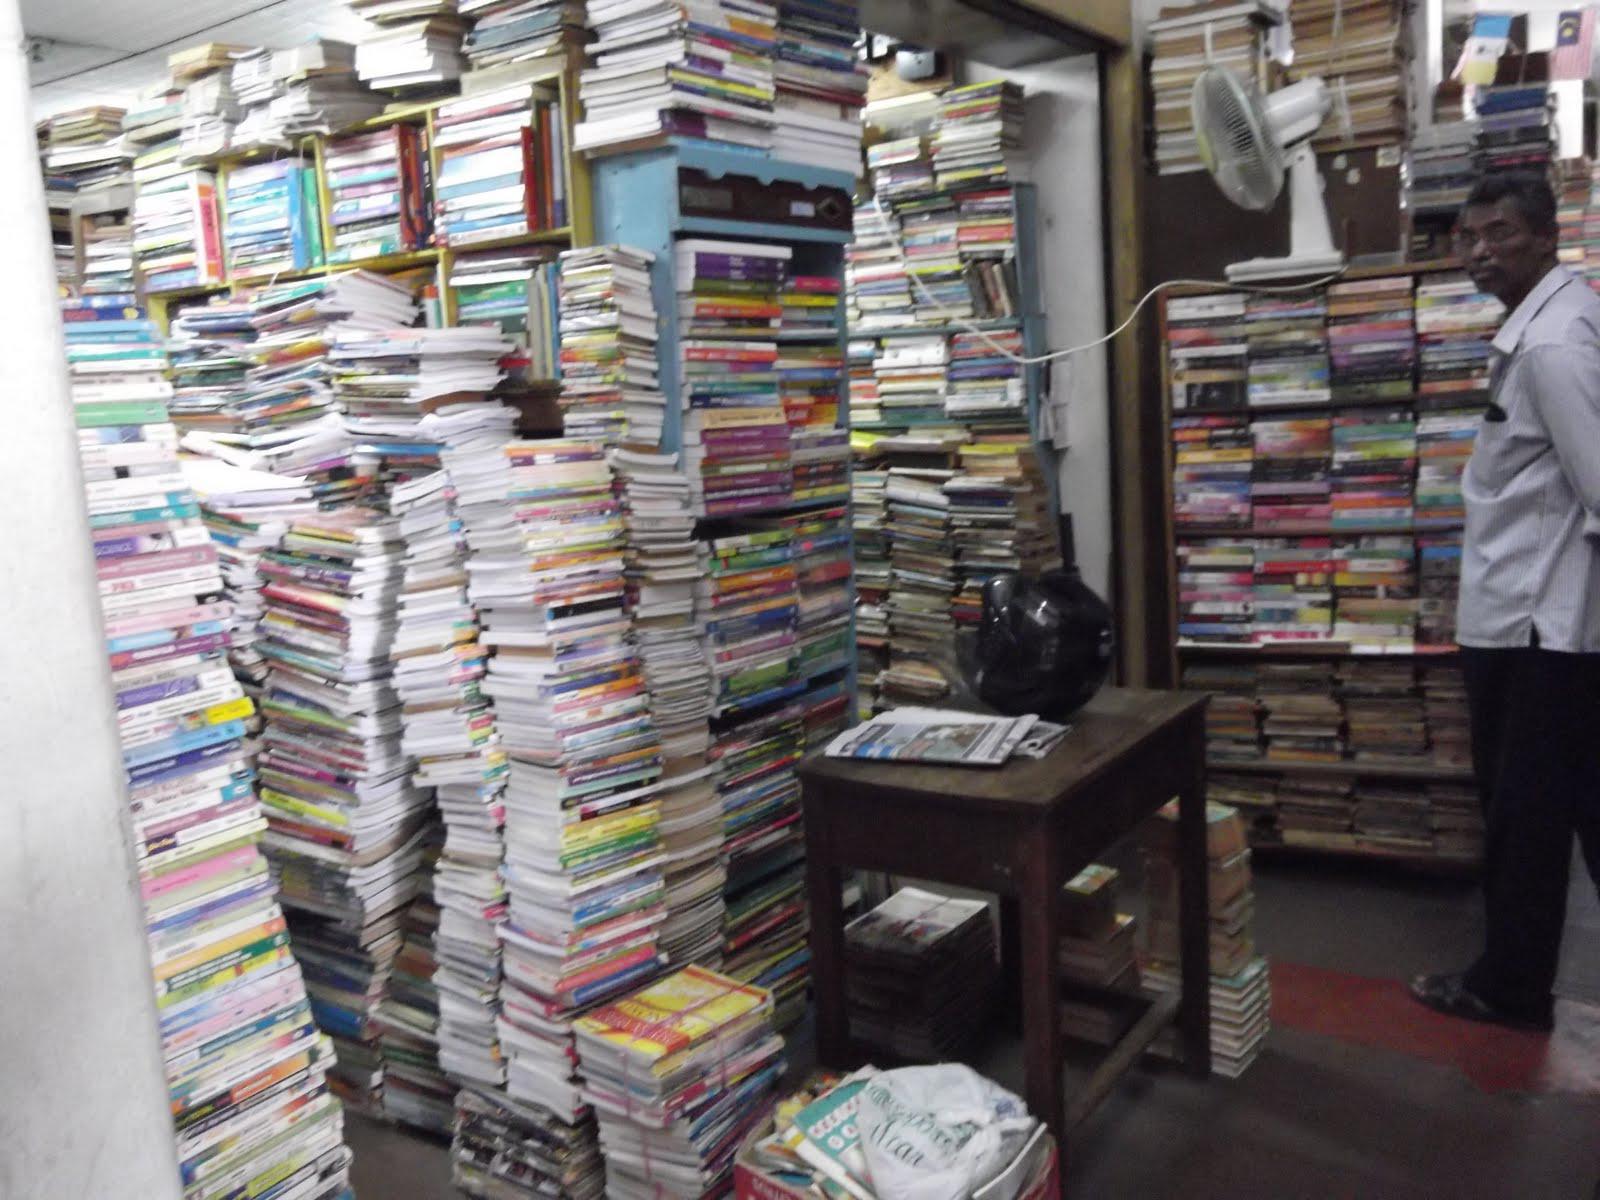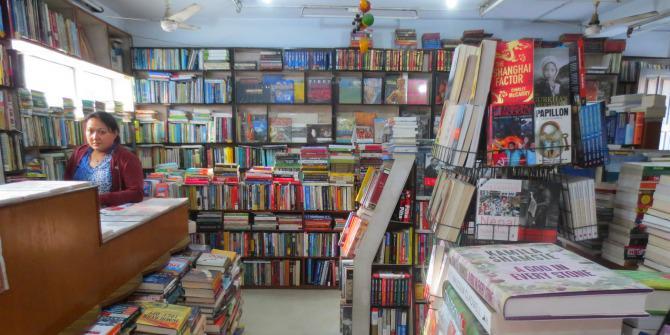The first image is the image on the left, the second image is the image on the right. Examine the images to the left and right. Is the description "There is a person behind the counter of a bookstore that has at least four separate bookshelves." accurate? Answer yes or no. Yes. 